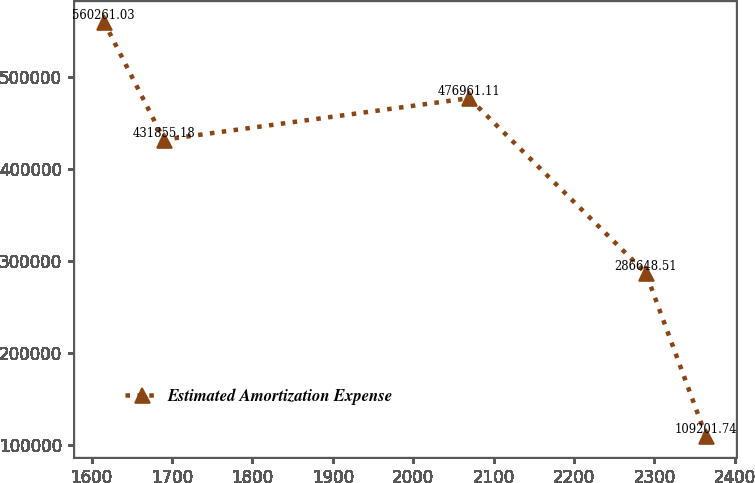<chart> <loc_0><loc_0><loc_500><loc_500><line_chart><ecel><fcel>Estimated Amortization Expense<nl><fcel>1615.15<fcel>560261<nl><fcel>1689.99<fcel>431855<nl><fcel>2069.58<fcel>476961<nl><fcel>2289.49<fcel>286649<nl><fcel>2364.33<fcel>109202<nl></chart> 